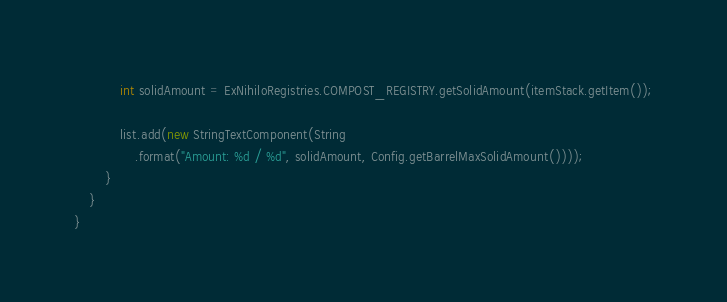Convert code to text. <code><loc_0><loc_0><loc_500><loc_500><_Java_>            int solidAmount = ExNihiloRegistries.COMPOST_REGISTRY.getSolidAmount(itemStack.getItem());

            list.add(new StringTextComponent(String
                .format("Amount: %d / %d", solidAmount, Config.getBarrelMaxSolidAmount())));
        }
    }
}
</code> 